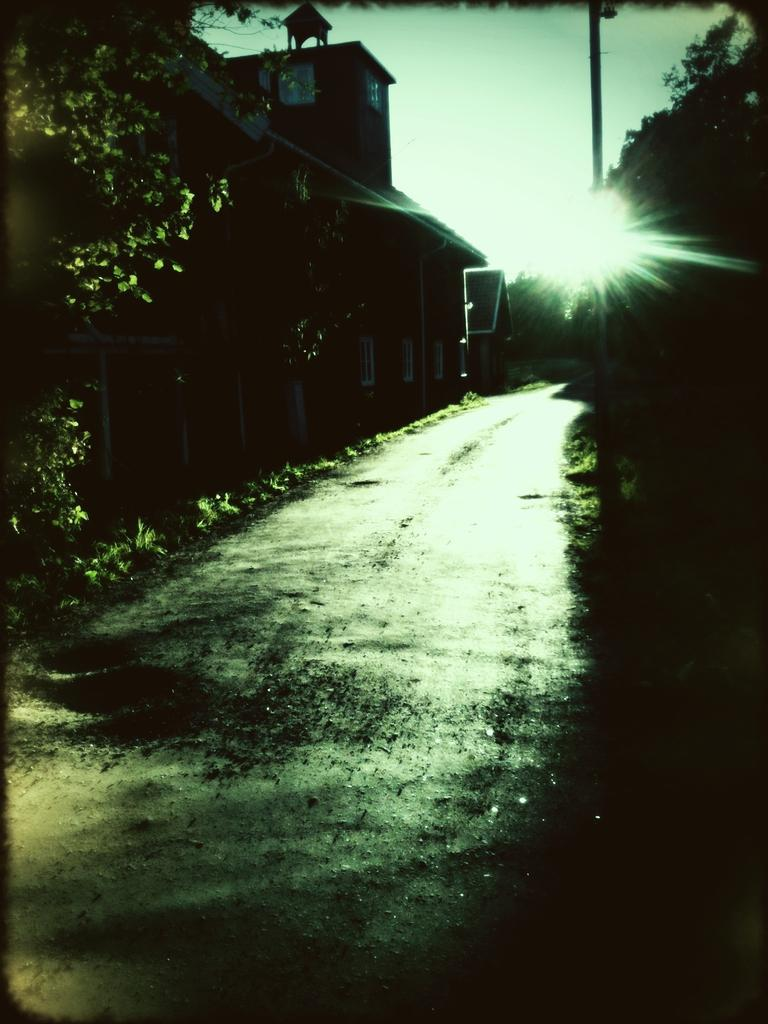What is the main feature of the image? There is a walkway in the image. What type of structures can be seen in the image? There are houses in the image. What is located on the right side of the houses? There is a pole and trees on the right side of the houses. What can be seen behind the houses in the image? The sky is visible behind the houses. What color of the eye of the person in the image? There are no people present in the image, so there is no eye to observe. 